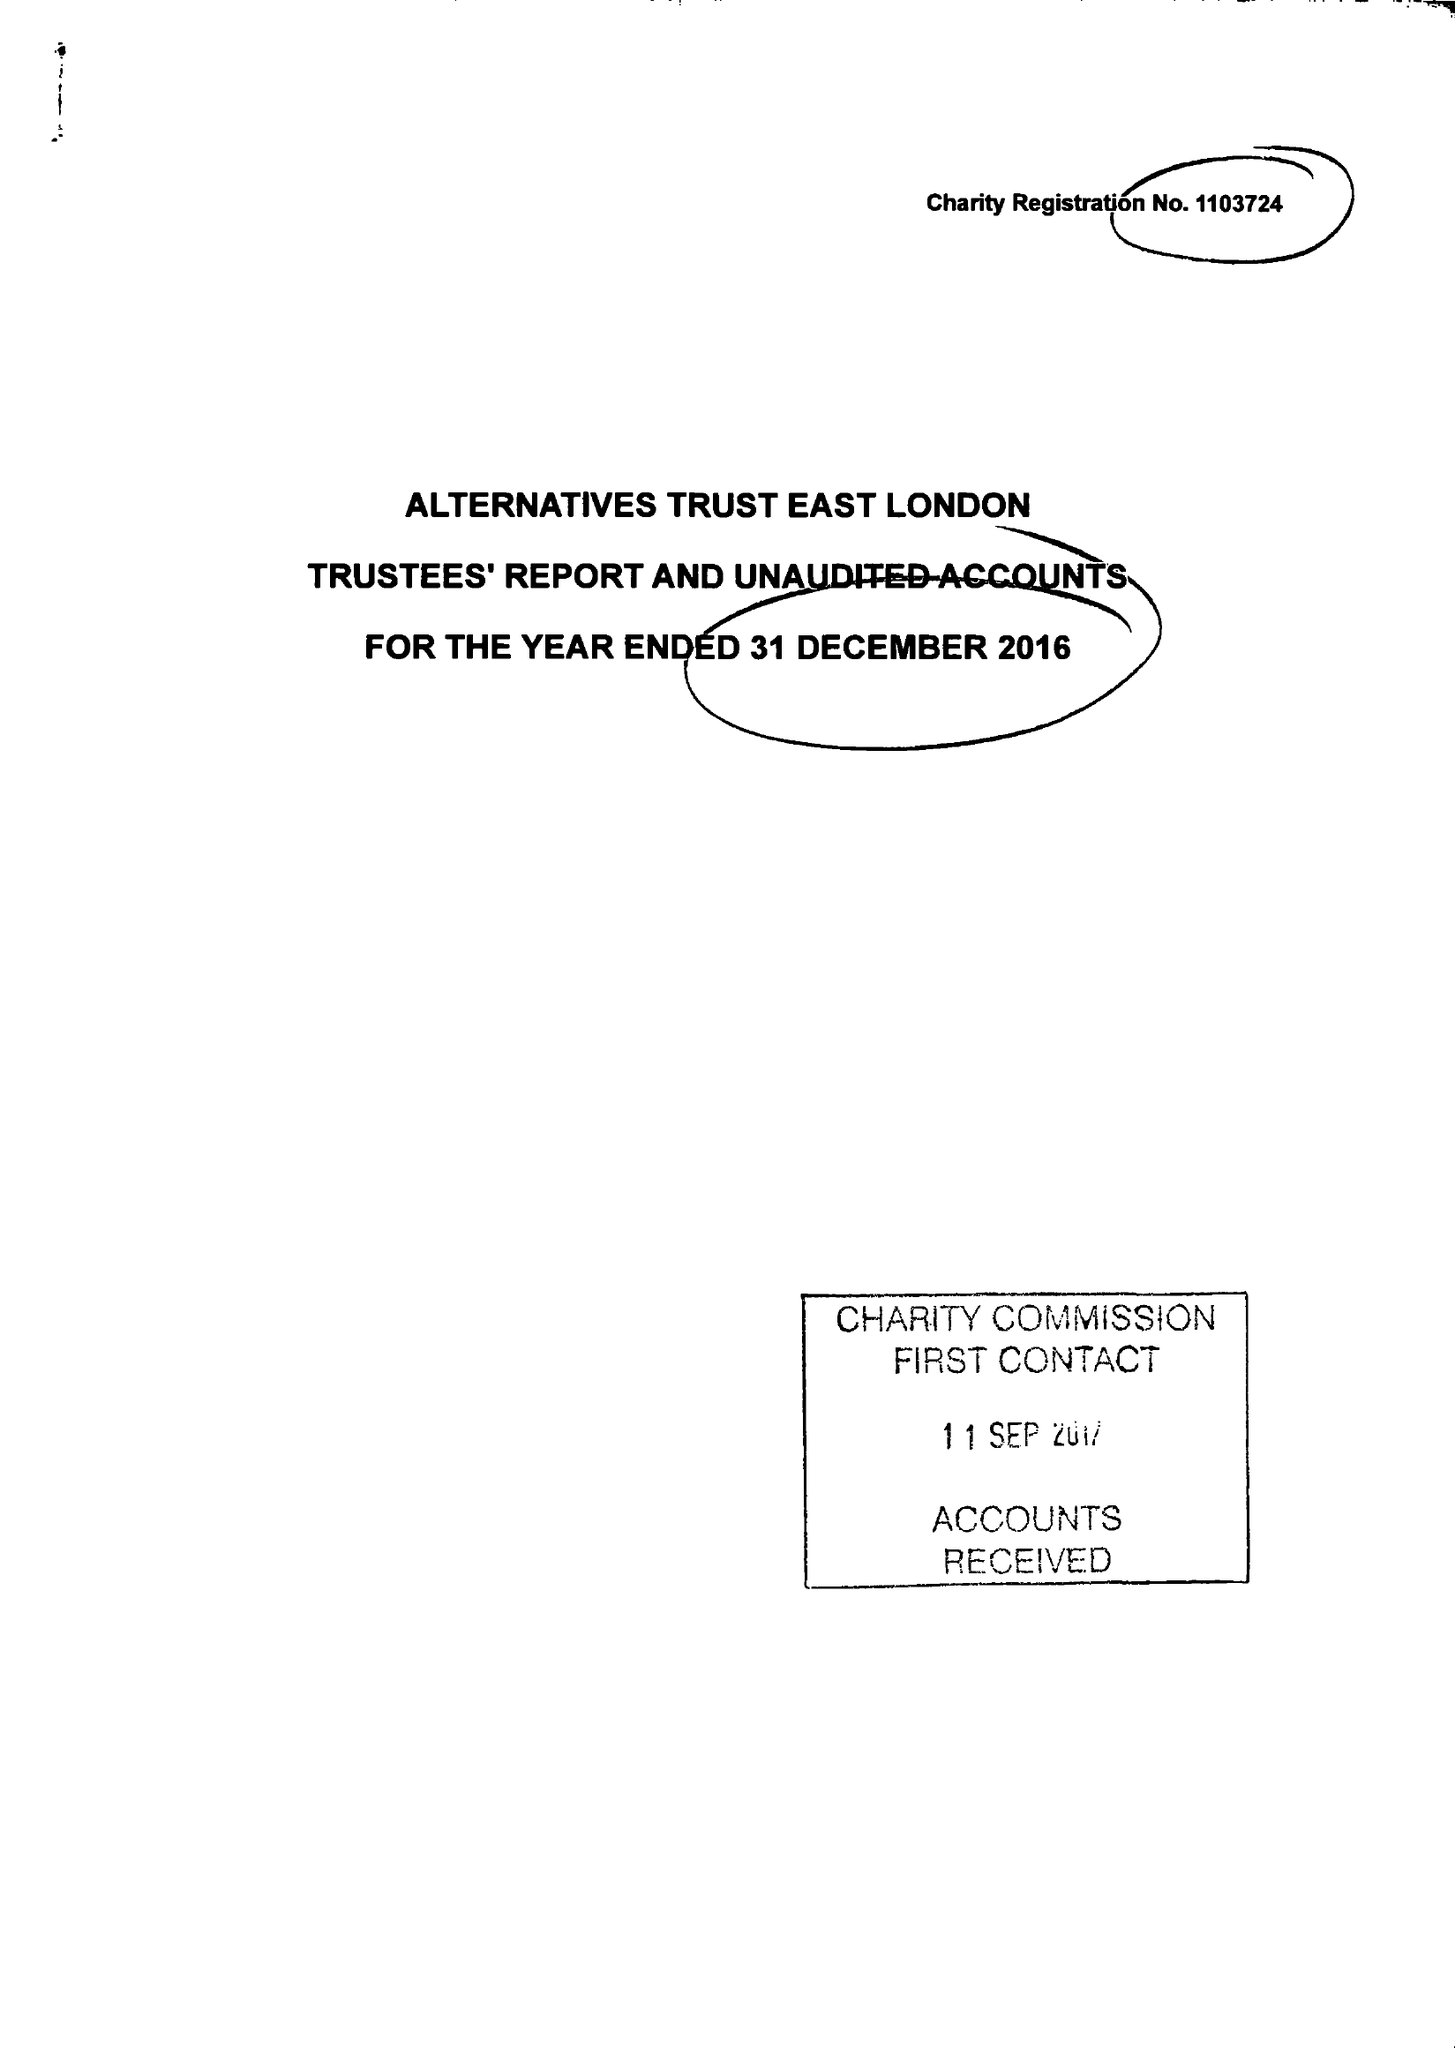What is the value for the charity_name?
Answer the question using a single word or phrase. Alternatives Trust East London 